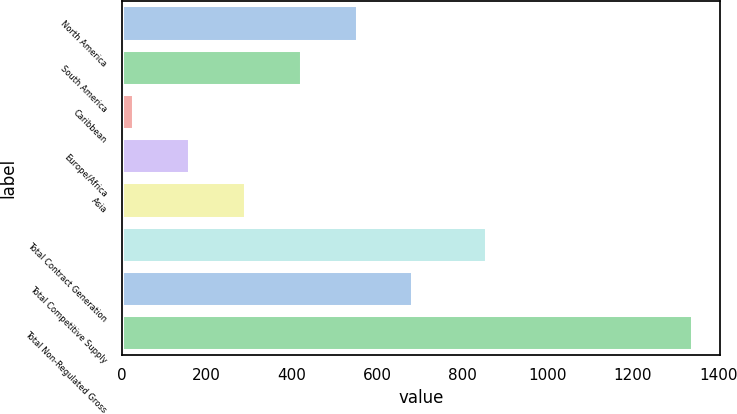<chart> <loc_0><loc_0><loc_500><loc_500><bar_chart><fcel>North America<fcel>South America<fcel>Caribbean<fcel>Europe/Africa<fcel>Asia<fcel>Total Contract Generation<fcel>Total Competitive Supply<fcel>Total Non-Regulated Gross<nl><fcel>551.4<fcel>420.3<fcel>27<fcel>158.1<fcel>289.2<fcel>854<fcel>682.5<fcel>1338<nl></chart> 